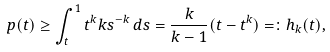<formula> <loc_0><loc_0><loc_500><loc_500>p ( t ) \geq \int _ { t } ^ { 1 } t ^ { k } k s ^ { - k } \, d s = \frac { k } { k - 1 } ( t - t ^ { k } ) = \colon h _ { k } ( t ) ,</formula> 